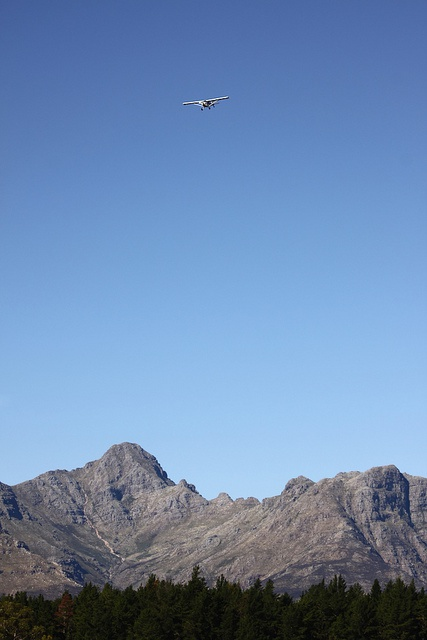Describe the objects in this image and their specific colors. I can see a airplane in blue, lightgray, black, and gray tones in this image. 